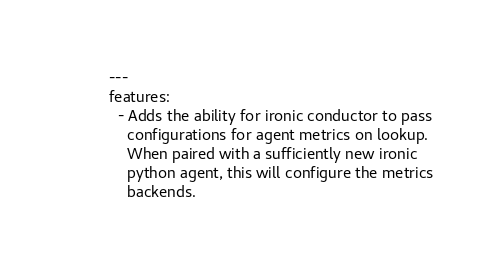<code> <loc_0><loc_0><loc_500><loc_500><_YAML_>---
features:
  - Adds the ability for ironic conductor to pass
    configurations for agent metrics on lookup.
    When paired with a sufficiently new ironic
    python agent, this will configure the metrics
    backends.
</code> 